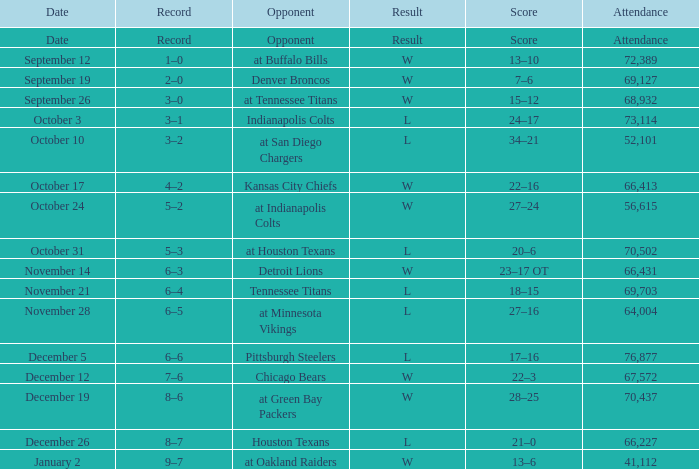Give me the full table as a dictionary. {'header': ['Date', 'Record', 'Opponent', 'Result', 'Score', 'Attendance'], 'rows': [['Date', 'Record', 'Opponent', 'Result', 'Score', 'Attendance'], ['September 12', '1–0', 'at Buffalo Bills', 'W', '13–10', '72,389'], ['September 19', '2–0', 'Denver Broncos', 'W', '7–6', '69,127'], ['September 26', '3–0', 'at Tennessee Titans', 'W', '15–12', '68,932'], ['October 3', '3–1', 'Indianapolis Colts', 'L', '24–17', '73,114'], ['October 10', '3–2', 'at San Diego Chargers', 'L', '34–21', '52,101'], ['October 17', '4–2', 'Kansas City Chiefs', 'W', '22–16', '66,413'], ['October 24', '5–2', 'at Indianapolis Colts', 'W', '27–24', '56,615'], ['October 31', '5–3', 'at Houston Texans', 'L', '20–6', '70,502'], ['November 14', '6–3', 'Detroit Lions', 'W', '23–17 OT', '66,431'], ['November 21', '6–4', 'Tennessee Titans', 'L', '18–15', '69,703'], ['November 28', '6–5', 'at Minnesota Vikings', 'L', '27–16', '64,004'], ['December 5', '6–6', 'Pittsburgh Steelers', 'L', '17–16', '76,877'], ['December 12', '7–6', 'Chicago Bears', 'W', '22–3', '67,572'], ['December 19', '8–6', 'at Green Bay Packers', 'W', '28–25', '70,437'], ['December 26', '8–7', 'Houston Texans', 'L', '21–0', '66,227'], ['January 2', '9–7', 'at Oakland Raiders', 'W', '13–6', '41,112']]} What record has w as the result, with January 2 as the date? 9–7. 